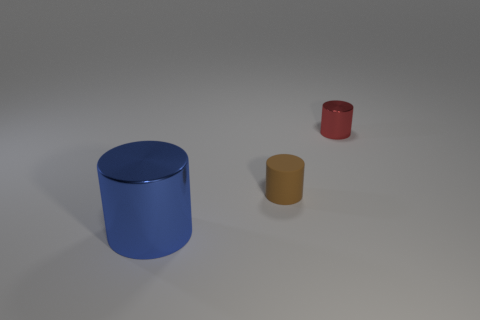Do the tiny metal object and the small rubber cylinder have the same color?
Your response must be concise. No. There is a shiny object that is behind the large metallic thing; is its shape the same as the small object in front of the red thing?
Provide a succinct answer. Yes. What material is the tiny red object that is the same shape as the brown object?
Keep it short and to the point. Metal. The cylinder that is both on the left side of the tiny red shiny thing and behind the large blue thing is what color?
Make the answer very short. Brown. Is there a tiny object in front of the tiny object to the left of the shiny thing that is right of the blue cylinder?
Offer a very short reply. No. How many things are big blue metal cylinders or small cylinders?
Provide a short and direct response. 3. Is the material of the brown object the same as the tiny object that is behind the rubber thing?
Offer a terse response. No. Are there any other things that have the same color as the small metallic object?
Offer a very short reply. No. How many things are either metal objects that are behind the large cylinder or things to the left of the small red shiny object?
Provide a short and direct response. 3. There is a object that is both in front of the red metallic cylinder and behind the big metallic object; what is its shape?
Provide a short and direct response. Cylinder. 